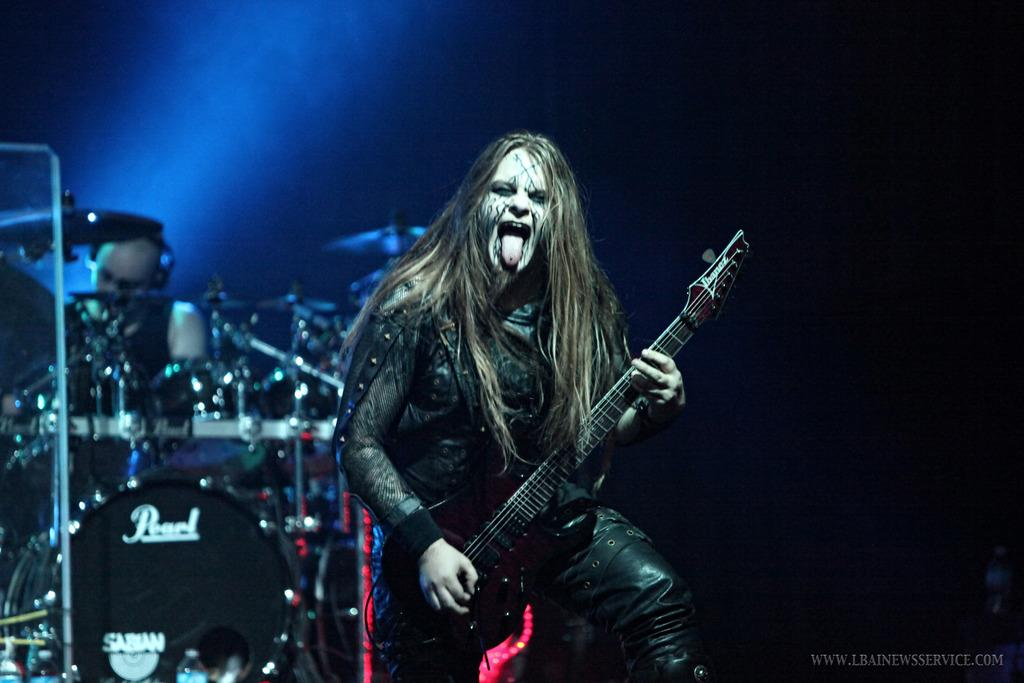What musical instruments are present in the image? There are drums in the image. How many people are in the image? There are two persons in the image. What is one person doing in the image? One person is standing and holding a guitar. How does the lock on the guitar work in the image? There is no lock on the guitar in the image; it is simply being held by one of the persons. 